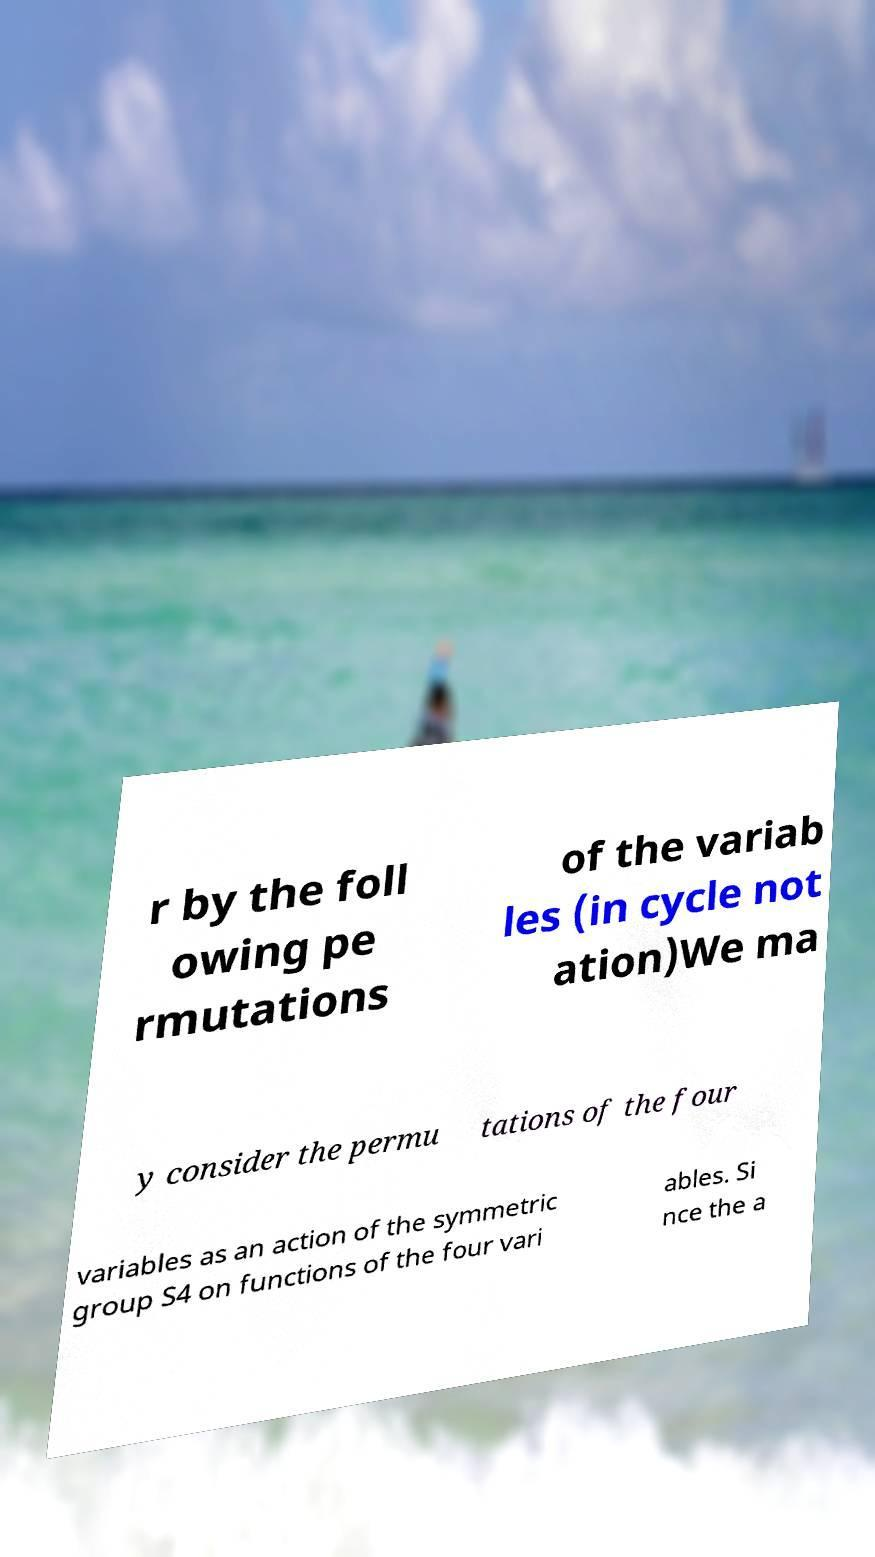Could you assist in decoding the text presented in this image and type it out clearly? r by the foll owing pe rmutations of the variab les (in cycle not ation)We ma y consider the permu tations of the four variables as an action of the symmetric group S4 on functions of the four vari ables. Si nce the a 